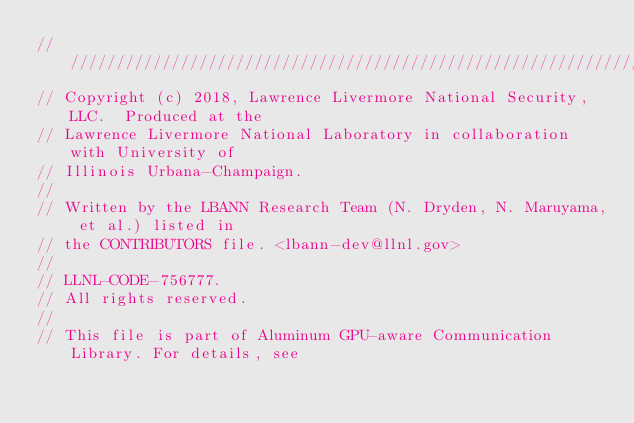Convert code to text. <code><loc_0><loc_0><loc_500><loc_500><_C++_>////////////////////////////////////////////////////////////////////////////////
// Copyright (c) 2018, Lawrence Livermore National Security, LLC.  Produced at the
// Lawrence Livermore National Laboratory in collaboration with University of
// Illinois Urbana-Champaign.
//
// Written by the LBANN Research Team (N. Dryden, N. Maruyama, et al.) listed in
// the CONTRIBUTORS file. <lbann-dev@llnl.gov>
//
// LLNL-CODE-756777.
// All rights reserved.
//
// This file is part of Aluminum GPU-aware Communication Library. For details, see</code> 